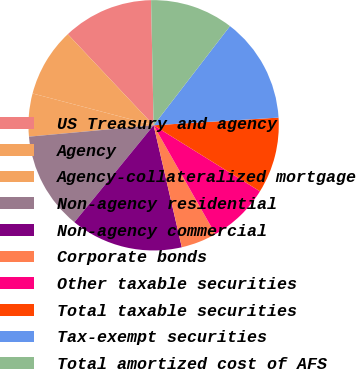Convert chart to OTSL. <chart><loc_0><loc_0><loc_500><loc_500><pie_chart><fcel>US Treasury and agency<fcel>Agency<fcel>Agency-collateralized mortgage<fcel>Non-agency residential<fcel>Non-agency commercial<fcel>Corporate bonds<fcel>Other taxable securities<fcel>Total taxable securities<fcel>Tax-exempt securities<fcel>Total amortized cost of AFS<nl><fcel>11.7%<fcel>8.88%<fcel>5.54%<fcel>12.64%<fcel>14.52%<fcel>4.6%<fcel>7.94%<fcel>9.82%<fcel>13.58%<fcel>10.76%<nl></chart> 